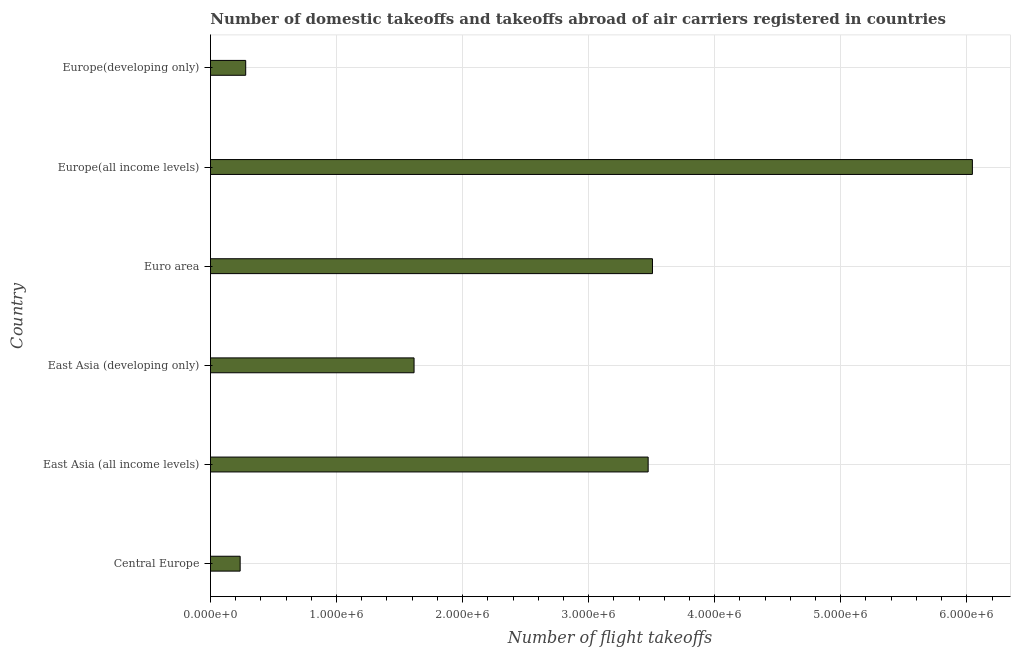What is the title of the graph?
Your response must be concise. Number of domestic takeoffs and takeoffs abroad of air carriers registered in countries. What is the label or title of the X-axis?
Keep it short and to the point. Number of flight takeoffs. What is the label or title of the Y-axis?
Give a very brief answer. Country. What is the number of flight takeoffs in Central Europe?
Provide a succinct answer. 2.35e+05. Across all countries, what is the maximum number of flight takeoffs?
Offer a terse response. 6.04e+06. Across all countries, what is the minimum number of flight takeoffs?
Offer a very short reply. 2.35e+05. In which country was the number of flight takeoffs maximum?
Provide a short and direct response. Europe(all income levels). In which country was the number of flight takeoffs minimum?
Provide a succinct answer. Central Europe. What is the sum of the number of flight takeoffs?
Offer a terse response. 1.52e+07. What is the difference between the number of flight takeoffs in Central Europe and East Asia (all income levels)?
Provide a short and direct response. -3.24e+06. What is the average number of flight takeoffs per country?
Give a very brief answer. 2.53e+06. What is the median number of flight takeoffs?
Your answer should be compact. 2.54e+06. In how many countries, is the number of flight takeoffs greater than 3400000 ?
Provide a short and direct response. 3. What is the ratio of the number of flight takeoffs in East Asia (all income levels) to that in East Asia (developing only)?
Offer a terse response. 2.15. Is the difference between the number of flight takeoffs in Euro area and Europe(developing only) greater than the difference between any two countries?
Ensure brevity in your answer.  No. What is the difference between the highest and the second highest number of flight takeoffs?
Give a very brief answer. 2.54e+06. Is the sum of the number of flight takeoffs in Europe(all income levels) and Europe(developing only) greater than the maximum number of flight takeoffs across all countries?
Your answer should be compact. Yes. What is the difference between the highest and the lowest number of flight takeoffs?
Offer a very short reply. 5.81e+06. How many countries are there in the graph?
Provide a short and direct response. 6. What is the Number of flight takeoffs in Central Europe?
Offer a terse response. 2.35e+05. What is the Number of flight takeoffs in East Asia (all income levels)?
Provide a short and direct response. 3.47e+06. What is the Number of flight takeoffs in East Asia (developing only)?
Offer a very short reply. 1.62e+06. What is the Number of flight takeoffs in Euro area?
Make the answer very short. 3.51e+06. What is the Number of flight takeoffs in Europe(all income levels)?
Your answer should be compact. 6.04e+06. What is the Number of flight takeoffs in Europe(developing only)?
Give a very brief answer. 2.80e+05. What is the difference between the Number of flight takeoffs in Central Europe and East Asia (all income levels)?
Provide a short and direct response. -3.24e+06. What is the difference between the Number of flight takeoffs in Central Europe and East Asia (developing only)?
Provide a short and direct response. -1.38e+06. What is the difference between the Number of flight takeoffs in Central Europe and Euro area?
Make the answer very short. -3.27e+06. What is the difference between the Number of flight takeoffs in Central Europe and Europe(all income levels)?
Provide a succinct answer. -5.81e+06. What is the difference between the Number of flight takeoffs in Central Europe and Europe(developing only)?
Keep it short and to the point. -4.41e+04. What is the difference between the Number of flight takeoffs in East Asia (all income levels) and East Asia (developing only)?
Your response must be concise. 1.86e+06. What is the difference between the Number of flight takeoffs in East Asia (all income levels) and Euro area?
Provide a succinct answer. -3.43e+04. What is the difference between the Number of flight takeoffs in East Asia (all income levels) and Europe(all income levels)?
Give a very brief answer. -2.57e+06. What is the difference between the Number of flight takeoffs in East Asia (all income levels) and Europe(developing only)?
Offer a terse response. 3.19e+06. What is the difference between the Number of flight takeoffs in East Asia (developing only) and Euro area?
Provide a short and direct response. -1.89e+06. What is the difference between the Number of flight takeoffs in East Asia (developing only) and Europe(all income levels)?
Provide a succinct answer. -4.43e+06. What is the difference between the Number of flight takeoffs in East Asia (developing only) and Europe(developing only)?
Provide a succinct answer. 1.34e+06. What is the difference between the Number of flight takeoffs in Euro area and Europe(all income levels)?
Offer a terse response. -2.54e+06. What is the difference between the Number of flight takeoffs in Euro area and Europe(developing only)?
Your answer should be very brief. 3.23e+06. What is the difference between the Number of flight takeoffs in Europe(all income levels) and Europe(developing only)?
Your answer should be very brief. 5.76e+06. What is the ratio of the Number of flight takeoffs in Central Europe to that in East Asia (all income levels)?
Keep it short and to the point. 0.07. What is the ratio of the Number of flight takeoffs in Central Europe to that in East Asia (developing only)?
Ensure brevity in your answer.  0.15. What is the ratio of the Number of flight takeoffs in Central Europe to that in Euro area?
Your answer should be compact. 0.07. What is the ratio of the Number of flight takeoffs in Central Europe to that in Europe(all income levels)?
Make the answer very short. 0.04. What is the ratio of the Number of flight takeoffs in Central Europe to that in Europe(developing only)?
Keep it short and to the point. 0.84. What is the ratio of the Number of flight takeoffs in East Asia (all income levels) to that in East Asia (developing only)?
Your answer should be compact. 2.15. What is the ratio of the Number of flight takeoffs in East Asia (all income levels) to that in Europe(all income levels)?
Provide a short and direct response. 0.57. What is the ratio of the Number of flight takeoffs in East Asia (all income levels) to that in Europe(developing only)?
Provide a short and direct response. 12.42. What is the ratio of the Number of flight takeoffs in East Asia (developing only) to that in Euro area?
Offer a terse response. 0.46. What is the ratio of the Number of flight takeoffs in East Asia (developing only) to that in Europe(all income levels)?
Your answer should be compact. 0.27. What is the ratio of the Number of flight takeoffs in East Asia (developing only) to that in Europe(developing only)?
Provide a succinct answer. 5.78. What is the ratio of the Number of flight takeoffs in Euro area to that in Europe(all income levels)?
Your answer should be very brief. 0.58. What is the ratio of the Number of flight takeoffs in Euro area to that in Europe(developing only)?
Your answer should be compact. 12.54. What is the ratio of the Number of flight takeoffs in Europe(all income levels) to that in Europe(developing only)?
Offer a very short reply. 21.62. 